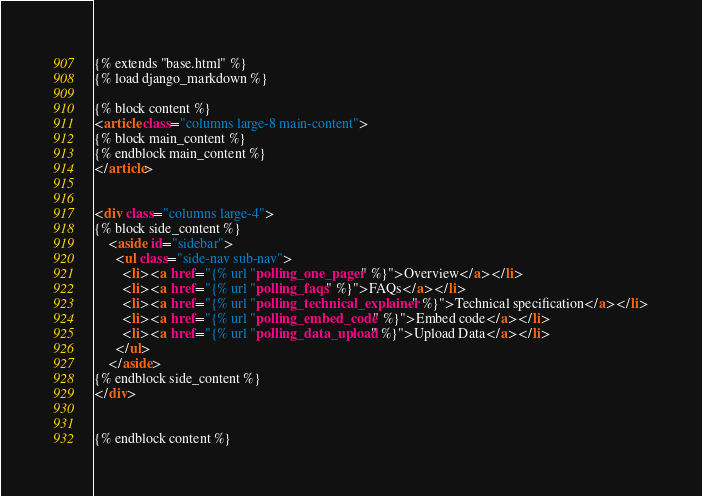<code> <loc_0><loc_0><loc_500><loc_500><_HTML_>{% extends "base.html" %}
{% load django_markdown %}

{% block content %}
<article class="columns large-8 main-content">
{% block main_content %}
{% endblock main_content %}
</article>


<div class="columns large-4">
{% block side_content %}
    <aside id="sidebar">
      <ul class="side-nav sub-nav">
        <li><a href="{% url "polling_one_pager" %}">Overview</a></li>
        <li><a href="{% url "polling_faqs" %}">FAQs</a></li>
        <li><a href="{% url "polling_technical_explainer" %}">Technical specification</a></li>
        <li><a href="{% url "polling_embed_code" %}">Embed code</a></li>
        <li><a href="{% url "polling_data_upload" %}">Upload Data</a></li>
      </ul>
    </aside>
{% endblock side_content %}
</div>


{% endblock content %}

</code> 